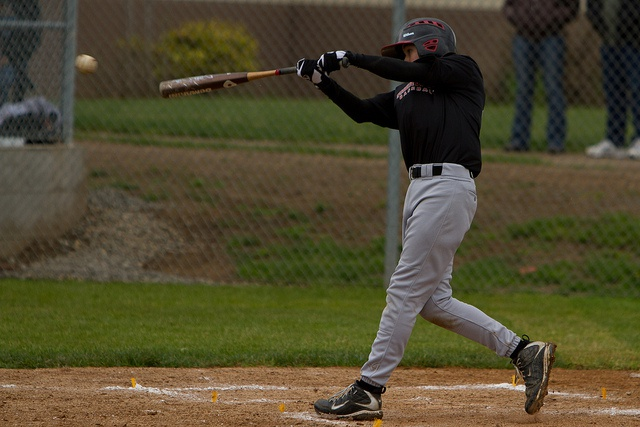Describe the objects in this image and their specific colors. I can see people in black, gray, and darkgreen tones, people in black and darkgreen tones, people in black, gray, and darkgreen tones, baseball bat in black, gray, darkgreen, and maroon tones, and baseball glove in black, gray, and darkgray tones in this image. 